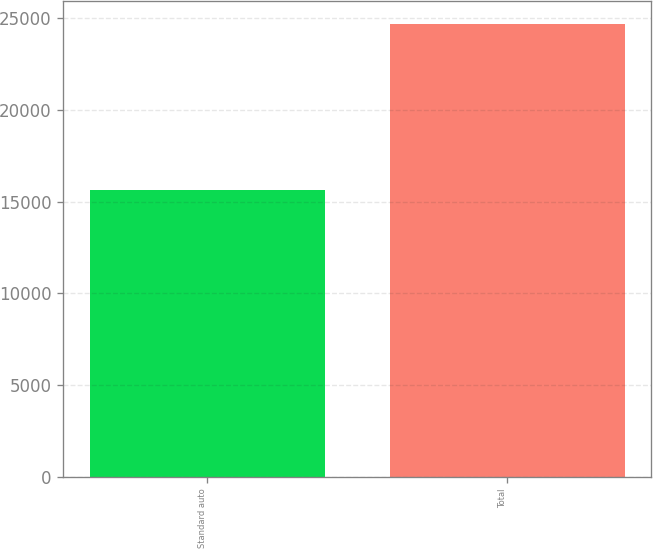Convert chart to OTSL. <chart><loc_0><loc_0><loc_500><loc_500><bar_chart><fcel>Standard auto<fcel>Total<nl><fcel>15637<fcel>24689<nl></chart> 